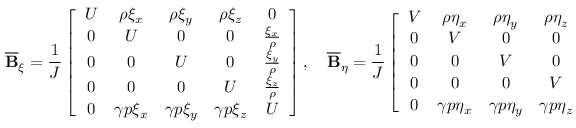<formula> <loc_0><loc_0><loc_500><loc_500>\overline { B } _ { \xi } = \frac { 1 } { J } \left [ \begin{array} { c c c c c } { U } & { \rho \xi _ { x } } & { \rho \xi _ { y } } & { \rho \xi _ { z } } & { 0 } \\ { 0 } & { U } & { 0 } & { 0 } & { \frac { \xi _ { x } } { \rho } } \\ { 0 } & { 0 } & { U } & { 0 } & { \frac { \xi _ { y } } { \rho } } \\ { 0 } & { 0 } & { 0 } & { U } & { \frac { \xi _ { z } } { \rho } } \\ { 0 } & { \gamma p \xi _ { x } } & { \gamma p \xi _ { y } } & { \gamma p \xi _ { z } } & { U } \end{array} \right ] , \quad \overline { B } _ { \eta } = \frac { 1 } { J } \left [ \begin{array} { c c c c c } { V } & { \rho \eta _ { x } } & { \rho \eta _ { y } } & { \rho \eta _ { z } } & { 0 } \\ { 0 } & { V } & { 0 } & { 0 } & { \frac { \eta _ { x } } { \rho } } \\ { 0 } & { 0 } & { V } & { 0 } & { \frac { \eta _ { y } } { \rho } } \\ { 0 } & { 0 } & { 0 } & { V } & { \frac { \eta _ { z } } { \rho } } \\ { 0 } & { \gamma p \eta _ { x } } & { \gamma p \eta _ { y } } & { \gamma p \eta _ { z } } & { V } \end{array} \right ] a n d</formula> 